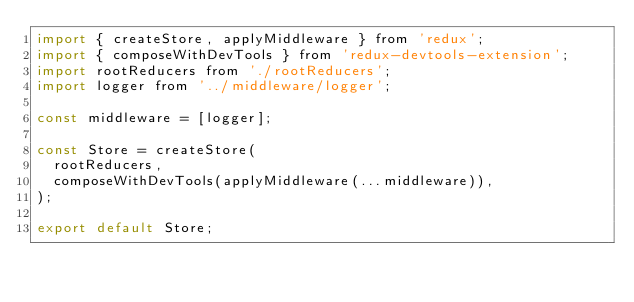<code> <loc_0><loc_0><loc_500><loc_500><_JavaScript_>import { createStore, applyMiddleware } from 'redux';
import { composeWithDevTools } from 'redux-devtools-extension';
import rootReducers from './rootReducers';
import logger from '../middleware/logger';

const middleware = [logger];

const Store = createStore(
  rootReducers,
  composeWithDevTools(applyMiddleware(...middleware)),
);

export default Store;
</code> 